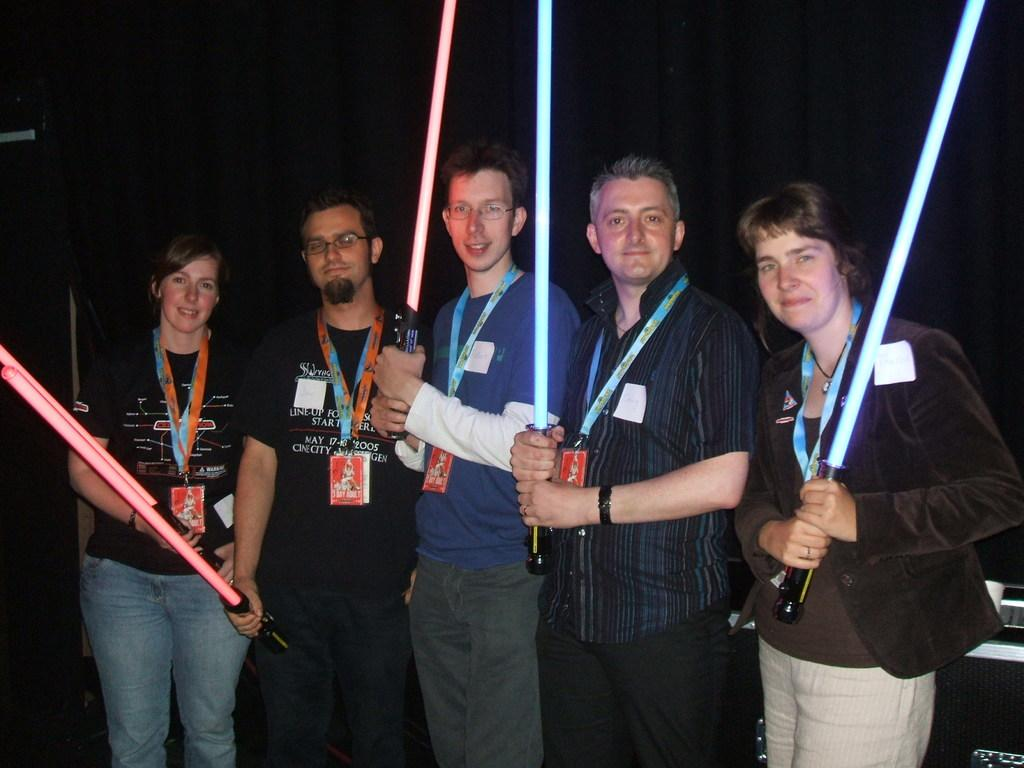Who or what can be seen in the image? There are people in the image. What are the people doing in the image? The people are holding objects. Can you describe any additional details about the people? The people are wearing access cards. What can be observed about the environment in the image? The background of the image is dark. What type of space exploration equipment can be seen in the image? There is no space exploration equipment present in the image. What religious beliefs are represented by the people in the image? The image does not provide any information about the religious beliefs of the people. 